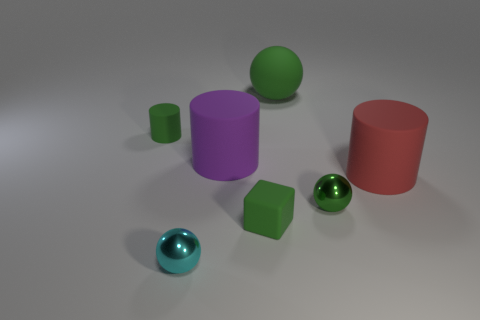Subtract all green spheres. How many spheres are left? 1 Subtract all blue cylinders. How many green balls are left? 2 Subtract 1 balls. How many balls are left? 2 Add 1 shiny objects. How many objects exist? 8 Subtract all blocks. How many objects are left? 6 Subtract all gray spheres. Subtract all gray blocks. How many spheres are left? 3 Subtract all purple cylinders. Subtract all big purple cylinders. How many objects are left? 5 Add 6 tiny green objects. How many tiny green objects are left? 9 Add 7 green cylinders. How many green cylinders exist? 8 Subtract 1 red cylinders. How many objects are left? 6 